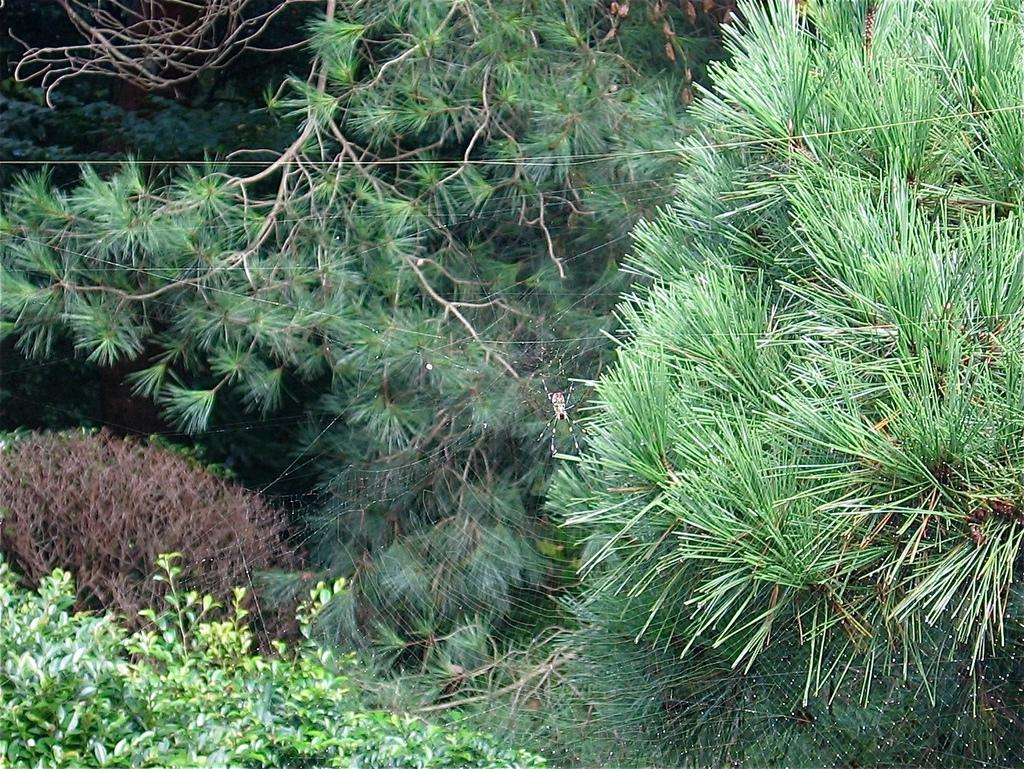What type of natural elements can be seen in the image? There are many trees and plants in the image. Can you describe any man-made elements in the image? There is a cable in the image. What position does the hat hold in the image? There is no hat present in the image. 